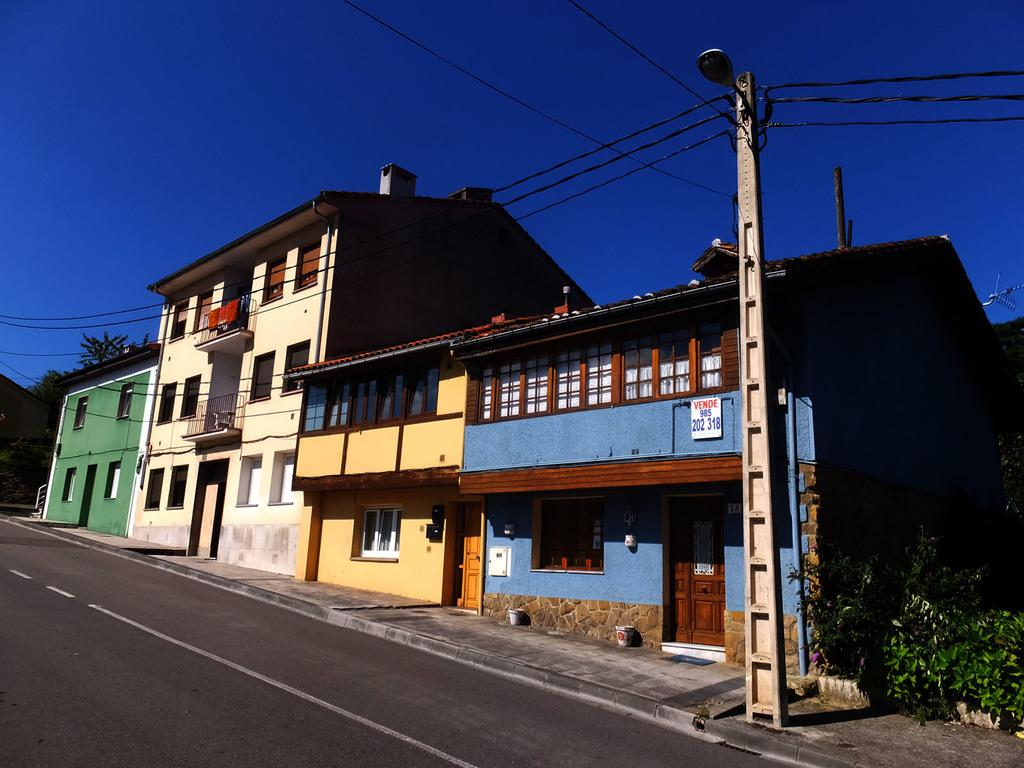What is the main feature of the image? There is a road in the image. What structures are located beside the road? There are houses beside the road. What type of vegetation can be seen in the image? There are trees in the image. What type of tooth can be seen in the image? There is no tooth present in the image. What type of building can be seen in the image? The image does not show any specific building; it only shows houses beside the road. 